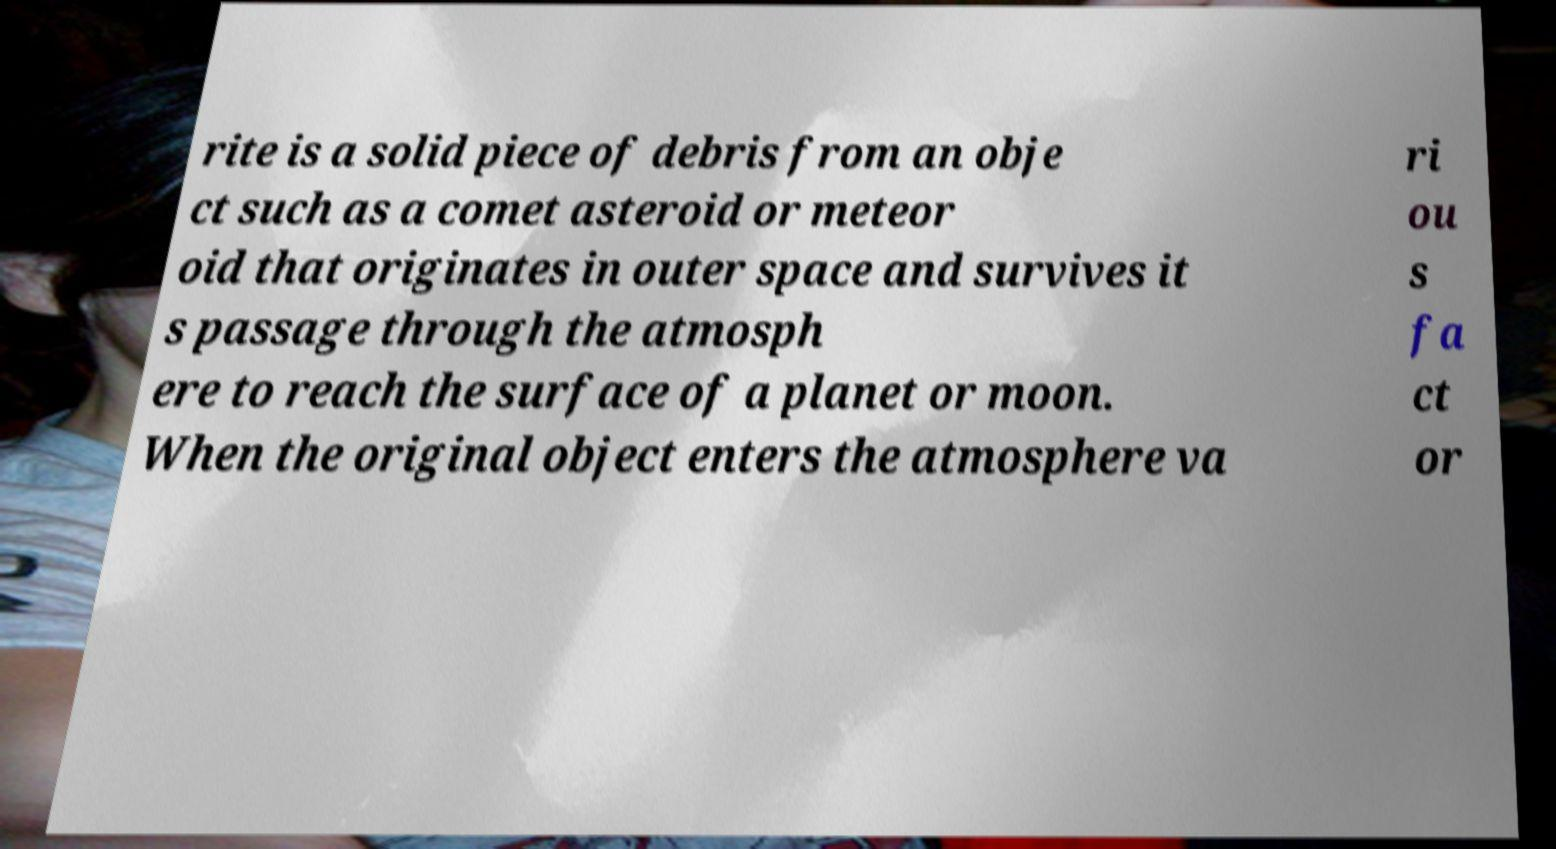There's text embedded in this image that I need extracted. Can you transcribe it verbatim? rite is a solid piece of debris from an obje ct such as a comet asteroid or meteor oid that originates in outer space and survives it s passage through the atmosph ere to reach the surface of a planet or moon. When the original object enters the atmosphere va ri ou s fa ct or 